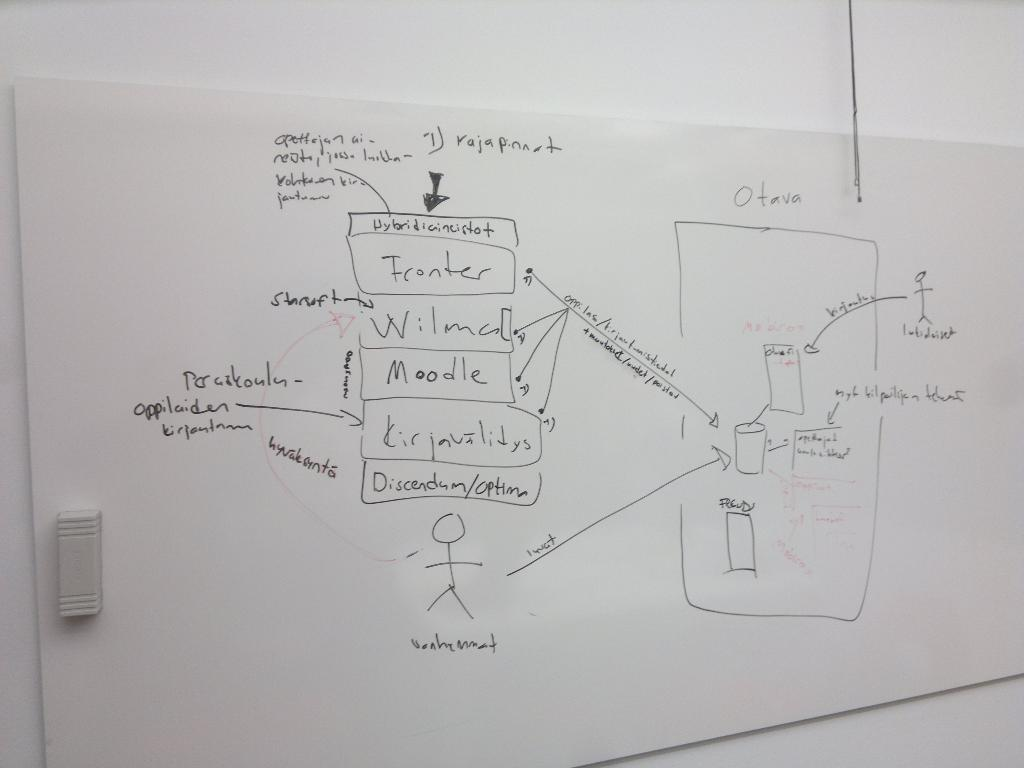<image>
Create a compact narrative representing the image presented. A whiteboard with things written in black, one word is Moodle. 